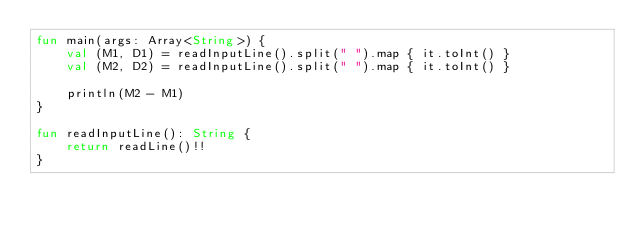<code> <loc_0><loc_0><loc_500><loc_500><_Kotlin_>fun main(args: Array<String>) {
    val (M1, D1) = readInputLine().split(" ").map { it.toInt() }
    val (M2, D2) = readInputLine().split(" ").map { it.toInt() }
    
    println(M2 - M1)
}

fun readInputLine(): String {
    return readLine()!!
}
</code> 